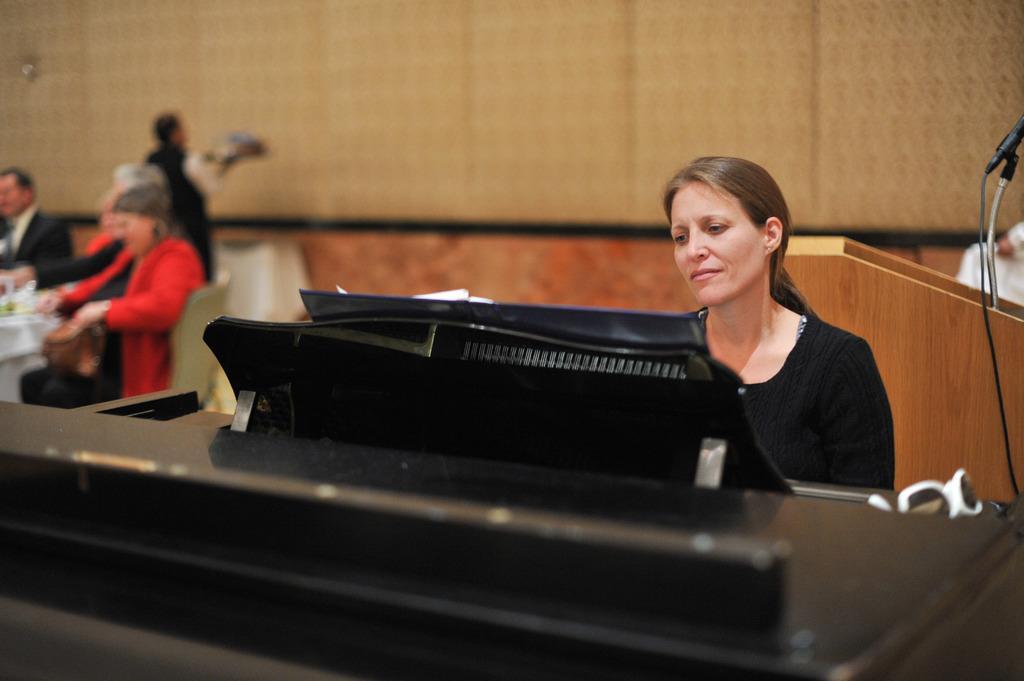In one or two sentences, can you explain what this image depicts? The picture is taken in a closed room and in the right corner of the picture a woman in the black dress sitting in front of the keyboard and looking to the book and at the right corner of the picture there are three people sitting upon the chairs in front of the table and behind them there is one person standing with something on his hands and in front of the person there is a big wall and coming to the right corner of the picture there is one podium with a speaker on it. 